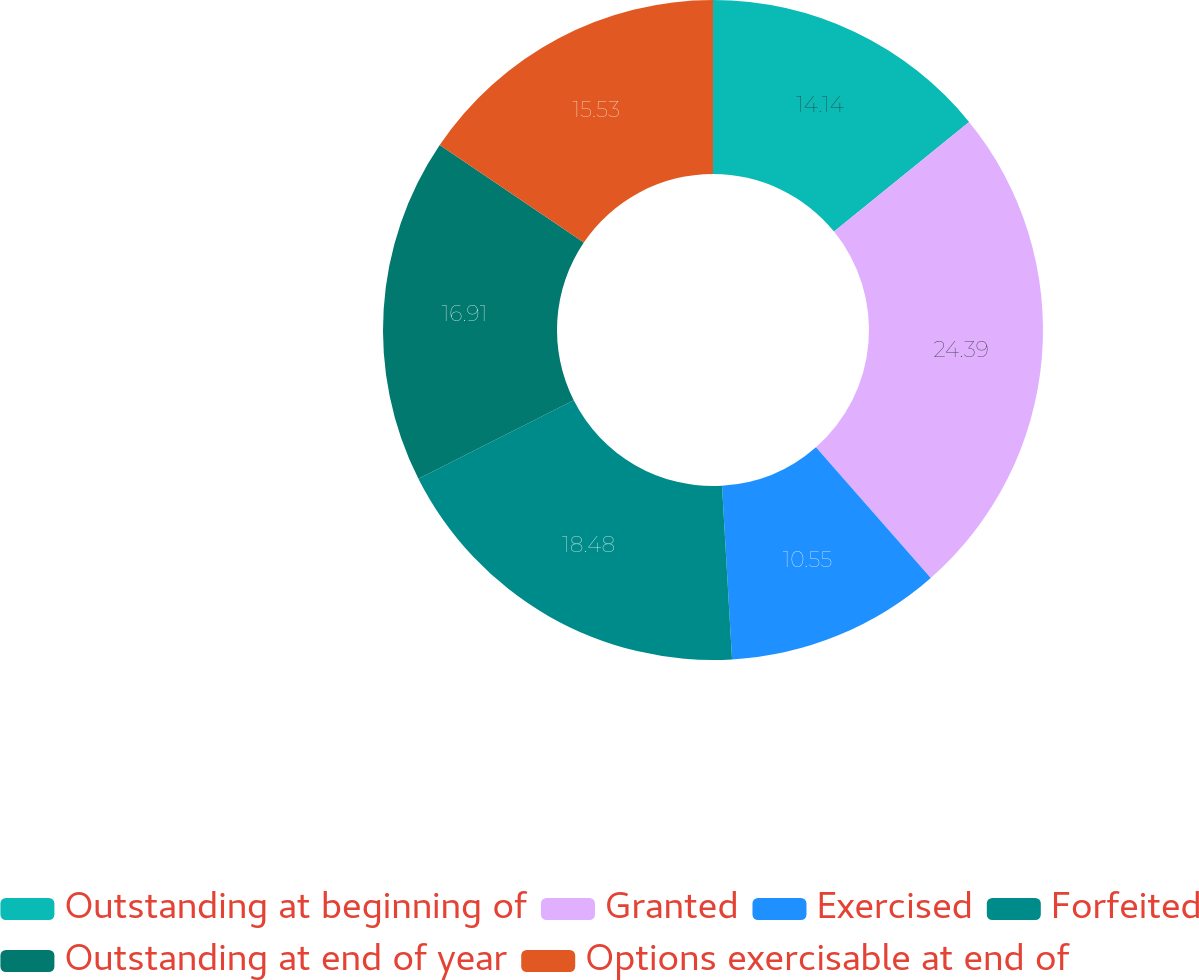Convert chart. <chart><loc_0><loc_0><loc_500><loc_500><pie_chart><fcel>Outstanding at beginning of<fcel>Granted<fcel>Exercised<fcel>Forfeited<fcel>Outstanding at end of year<fcel>Options exercisable at end of<nl><fcel>14.14%<fcel>24.39%<fcel>10.55%<fcel>18.48%<fcel>16.91%<fcel>15.53%<nl></chart> 